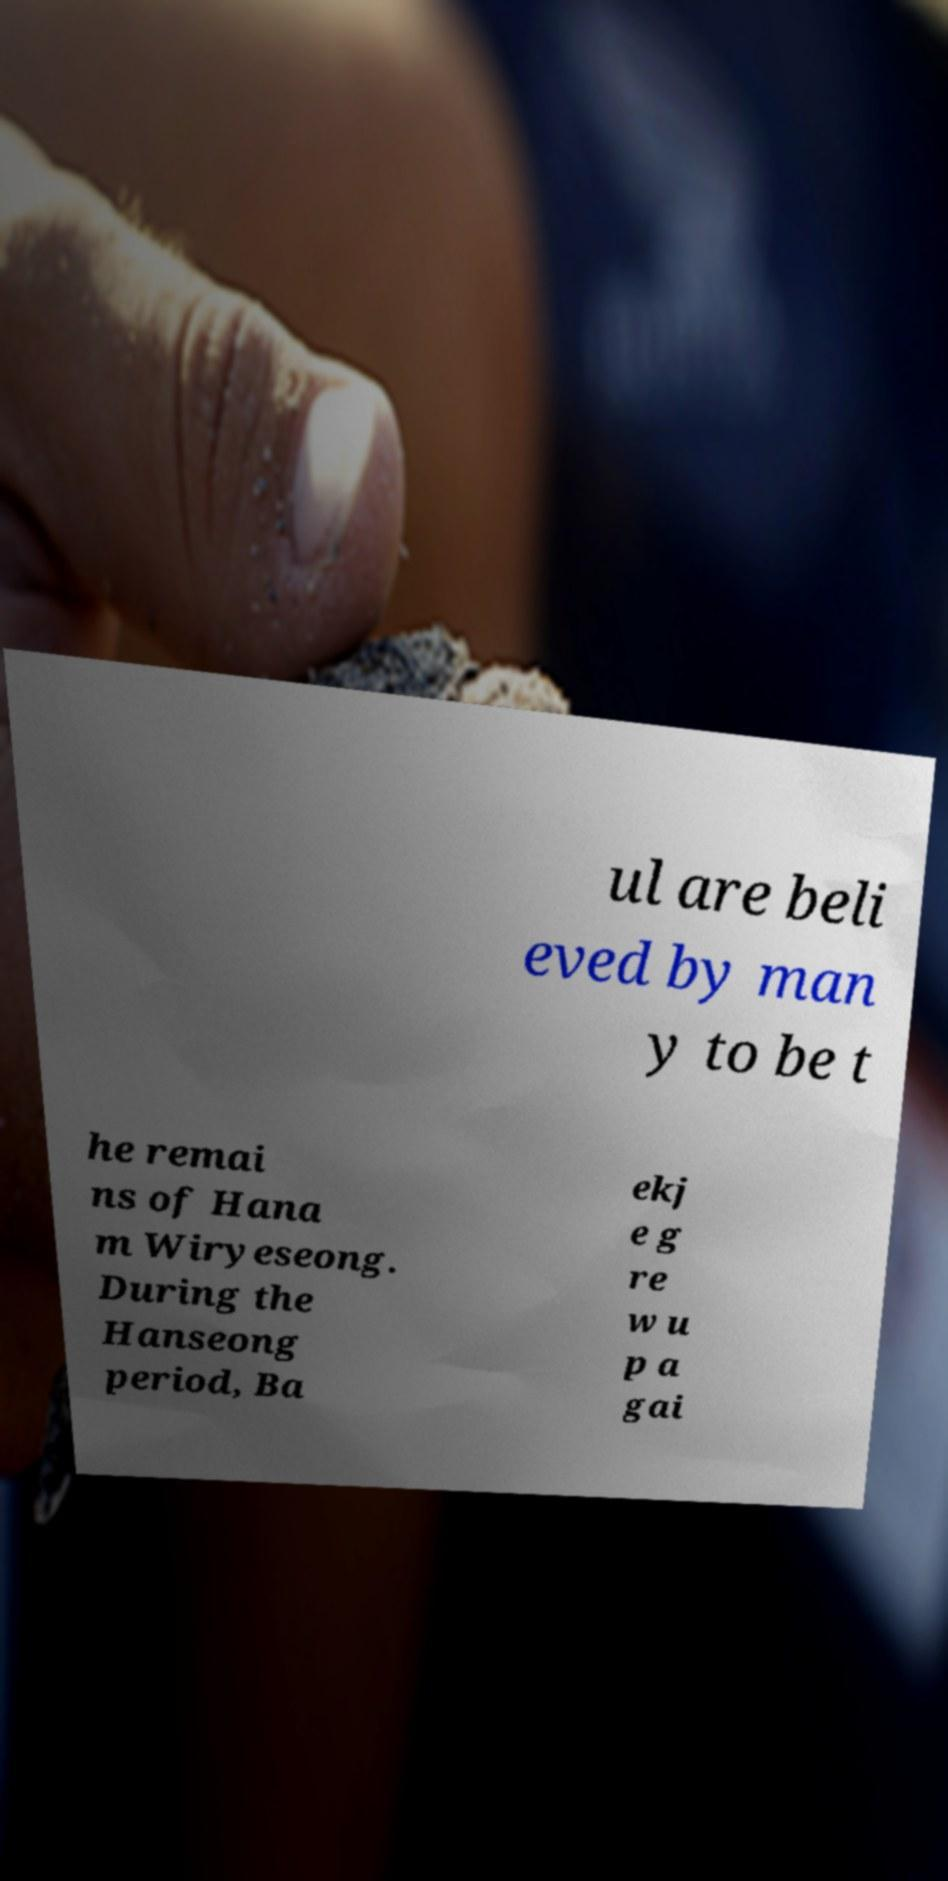I need the written content from this picture converted into text. Can you do that? ul are beli eved by man y to be t he remai ns of Hana m Wiryeseong. During the Hanseong period, Ba ekj e g re w u p a gai 